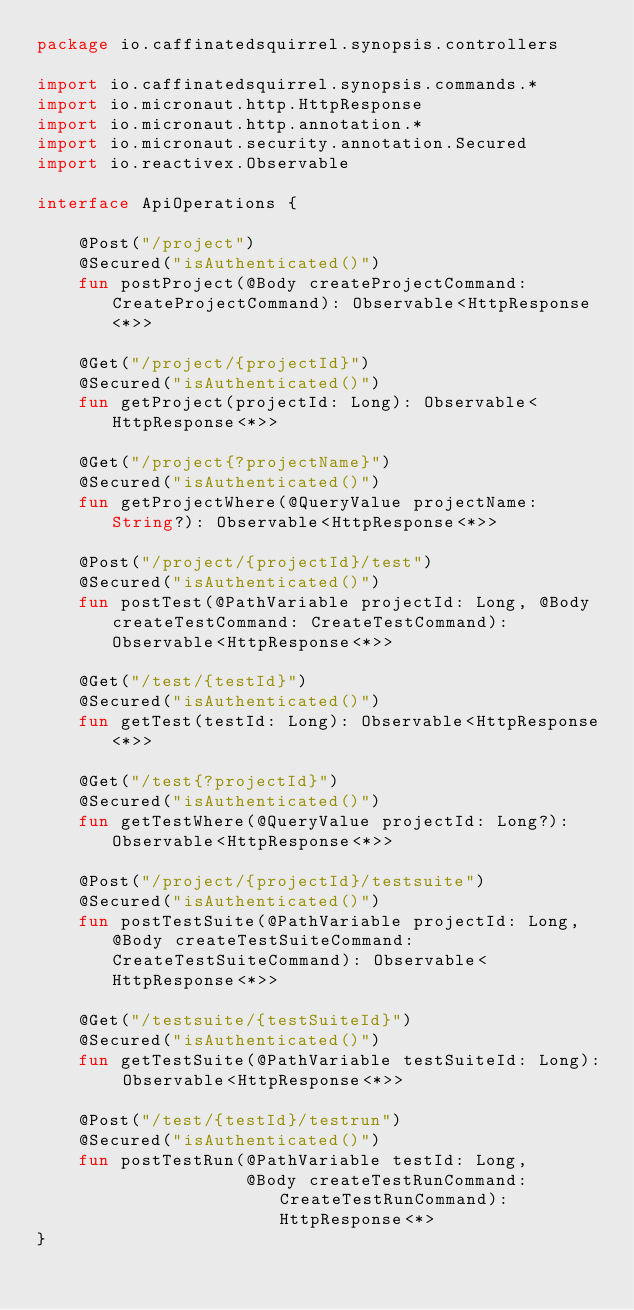Convert code to text. <code><loc_0><loc_0><loc_500><loc_500><_Kotlin_>package io.caffinatedsquirrel.synopsis.controllers

import io.caffinatedsquirrel.synopsis.commands.*
import io.micronaut.http.HttpResponse
import io.micronaut.http.annotation.*
import io.micronaut.security.annotation.Secured
import io.reactivex.Observable

interface ApiOperations {

    @Post("/project")
    @Secured("isAuthenticated()")
    fun postProject(@Body createProjectCommand: CreateProjectCommand): Observable<HttpResponse<*>>

    @Get("/project/{projectId}")
    @Secured("isAuthenticated()")
    fun getProject(projectId: Long): Observable<HttpResponse<*>>

    @Get("/project{?projectName}")
    @Secured("isAuthenticated()")
    fun getProjectWhere(@QueryValue projectName: String?): Observable<HttpResponse<*>>

    @Post("/project/{projectId}/test")
    @Secured("isAuthenticated()")
    fun postTest(@PathVariable projectId: Long, @Body createTestCommand: CreateTestCommand): Observable<HttpResponse<*>>

    @Get("/test/{testId}")
    @Secured("isAuthenticated()")
    fun getTest(testId: Long): Observable<HttpResponse<*>>

    @Get("/test{?projectId}")
    @Secured("isAuthenticated()")
    fun getTestWhere(@QueryValue projectId: Long?): Observable<HttpResponse<*>>

    @Post("/project/{projectId}/testsuite")
    @Secured("isAuthenticated()")
    fun postTestSuite(@PathVariable projectId: Long, @Body createTestSuiteCommand: CreateTestSuiteCommand): Observable<HttpResponse<*>>

    @Get("/testsuite/{testSuiteId}")
    @Secured("isAuthenticated()")
    fun getTestSuite(@PathVariable testSuiteId: Long): Observable<HttpResponse<*>>

    @Post("/test/{testId}/testrun")
    @Secured("isAuthenticated()")
    fun postTestRun(@PathVariable testId: Long,
                    @Body createTestRunCommand: CreateTestRunCommand): HttpResponse<*>
}</code> 